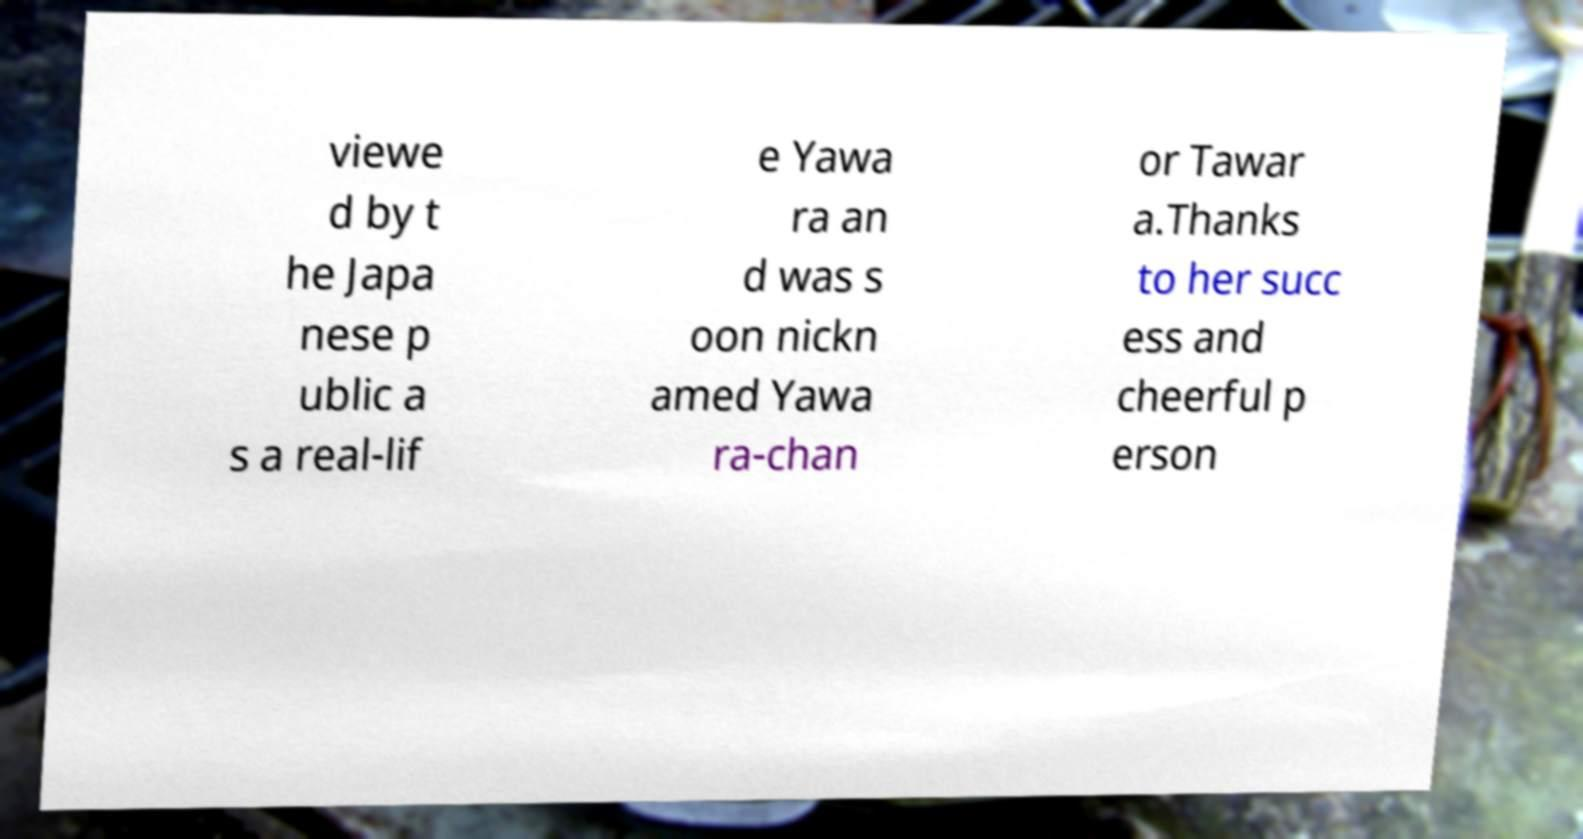Can you accurately transcribe the text from the provided image for me? viewe d by t he Japa nese p ublic a s a real-lif e Yawa ra an d was s oon nickn amed Yawa ra-chan or Tawar a.Thanks to her succ ess and cheerful p erson 